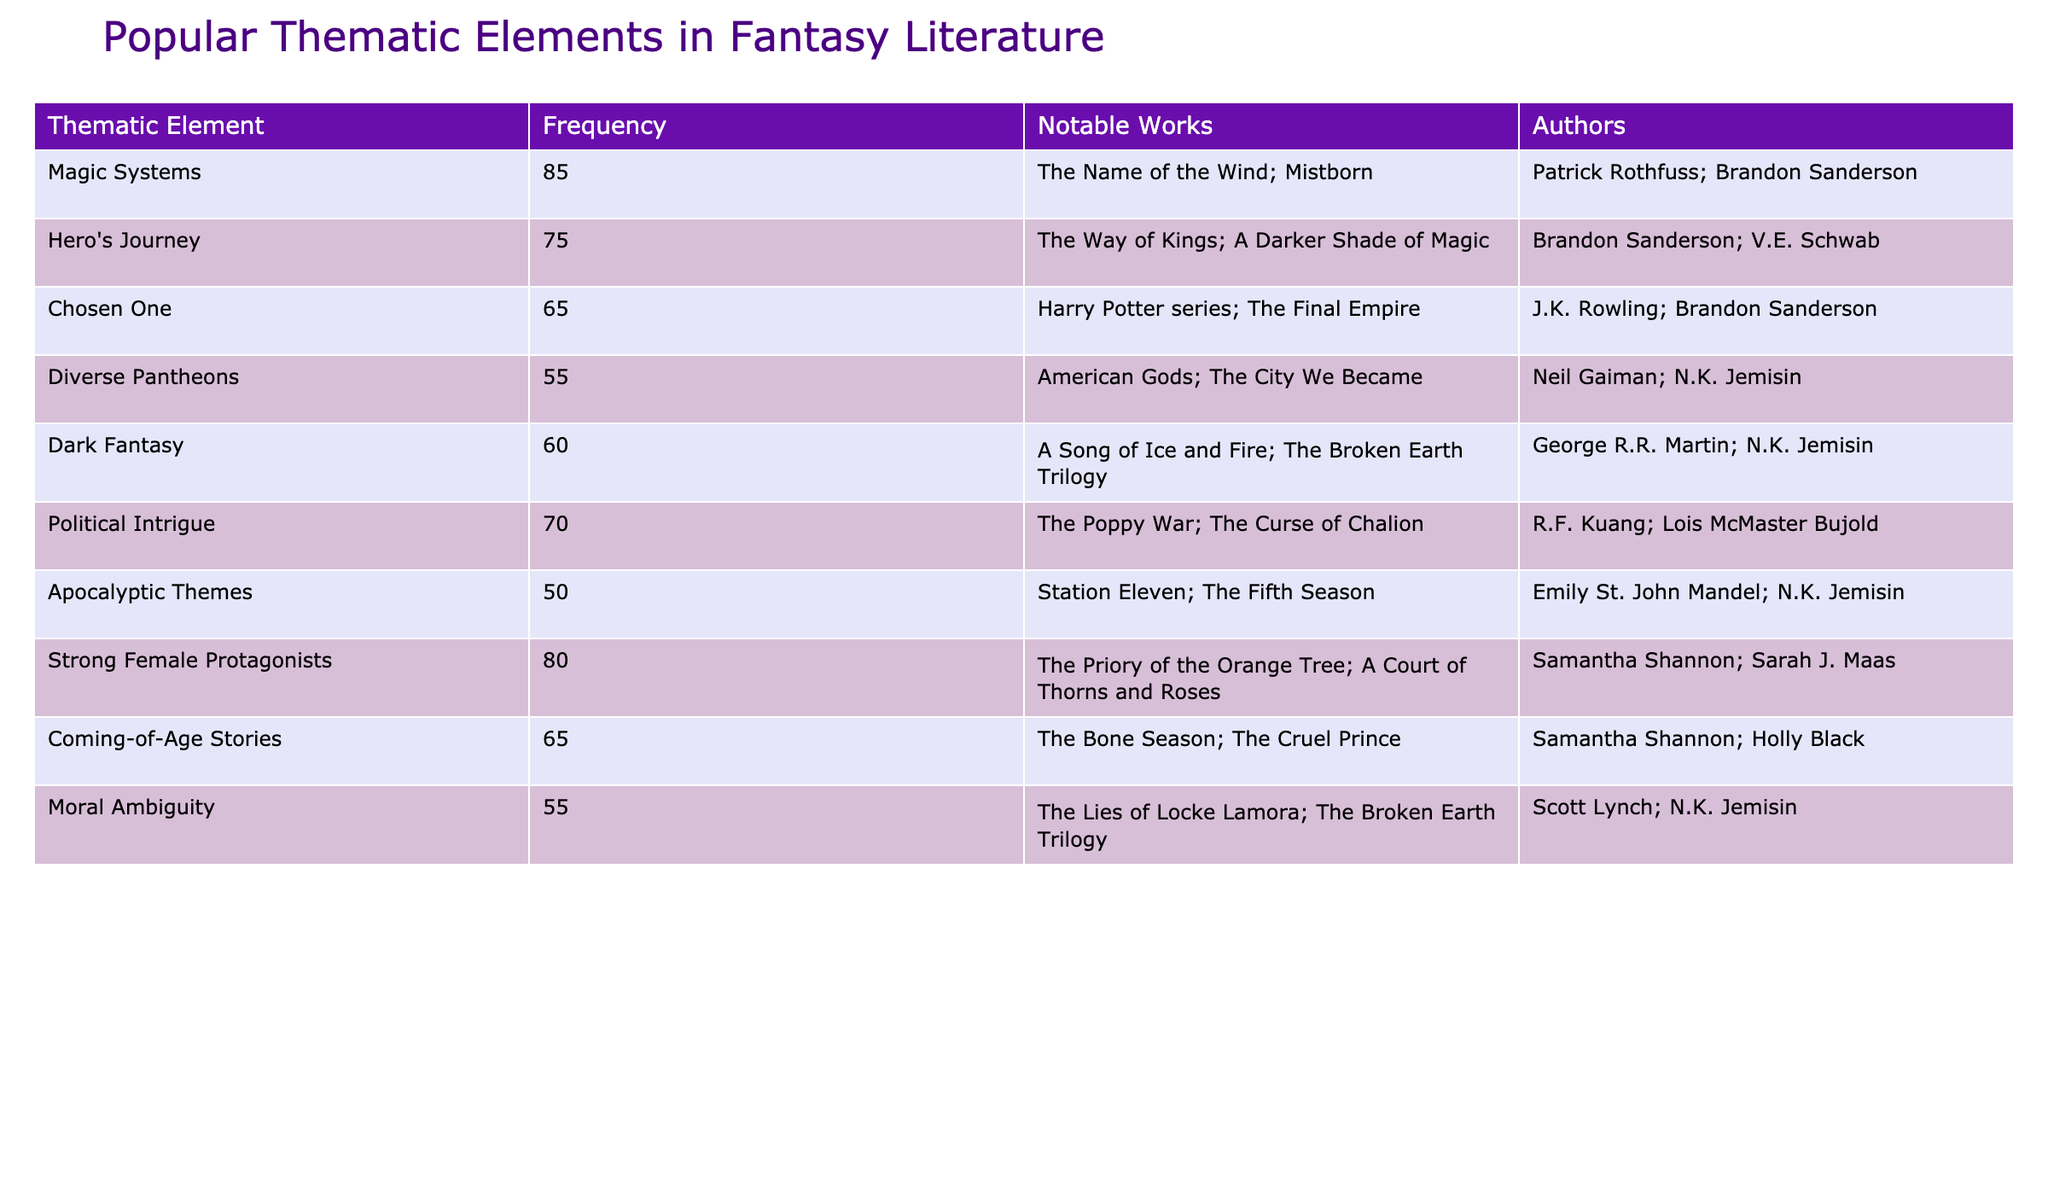What is the most frequent thematic element in the table? The theme with the highest frequency in the table is "Magic Systems," which has a frequency of 85.
Answer: Magic Systems Who are the authors associated with "Strong Female Protagonists"? The authors associated with this thematic element are Samantha Shannon and Sarah J. Maas, as listed in the table.
Answer: Samantha Shannon; Sarah J. Maas What is the total frequency of the themes related to the "Hero's Journey" and "Chosen One"? The frequency for "Hero's Journey" is 75 and for "Chosen One" is 65. Adding these gives 75 + 65 = 140.
Answer: 140 Is "Dark Fantasy" mentioned as one of the thematic elements? Yes, "Dark Fantasy" is listed among the thematic elements with a frequency of 60.
Answer: Yes Which thematic element has the lowest frequency? The thematic element with the lowest frequency is "Apocalyptic Themes," which has a frequency of 50.
Answer: Apocalyptic Themes How many thematic elements have a frequency of 70 or higher? There are four thematic elements—"Magic Systems," "Strong Female Protagonists," "Hero's Journey," and "Political Intrigue"—that meet this criterion: 85, 80, 75, and 70 respectively.
Answer: 4 What is the frequency difference between "Diverse Pantheons" and "Moral Ambiguity"? The frequency for "Diverse Pantheons" is 55 and for "Moral Ambiguity" it is also 55. Therefore, the difference is 55 - 55 = 0.
Answer: 0 Which authors wrote works associated with the "Chosen One" theme? The authors associated with this theme are J.K. Rowling and Brandon Sanderson, as indicated in the table.
Answer: J.K. Rowling; Brandon Sanderson What is the average frequency of the thematic elements listed? The frequencies of the thematic elements are 85, 75, 65, 55, 60, 70, 50, 80, 65, and 55. There are 10 elements, and their sum is 75 + 80 + 65 + 55 + 60 + 70 + 50 + 85 + 65 + 55 = 700. Thus, the average is 700 / 10 = 70.
Answer: 70 What percentage of the total thematic frequency does "Apocalyptic Themes" represent? The frequency of "Apocalyptic Themes" is 50, and the total frequency is 700. Hence, the percentage is (50 / 700) × 100 = 7.14%.
Answer: 7.14% 